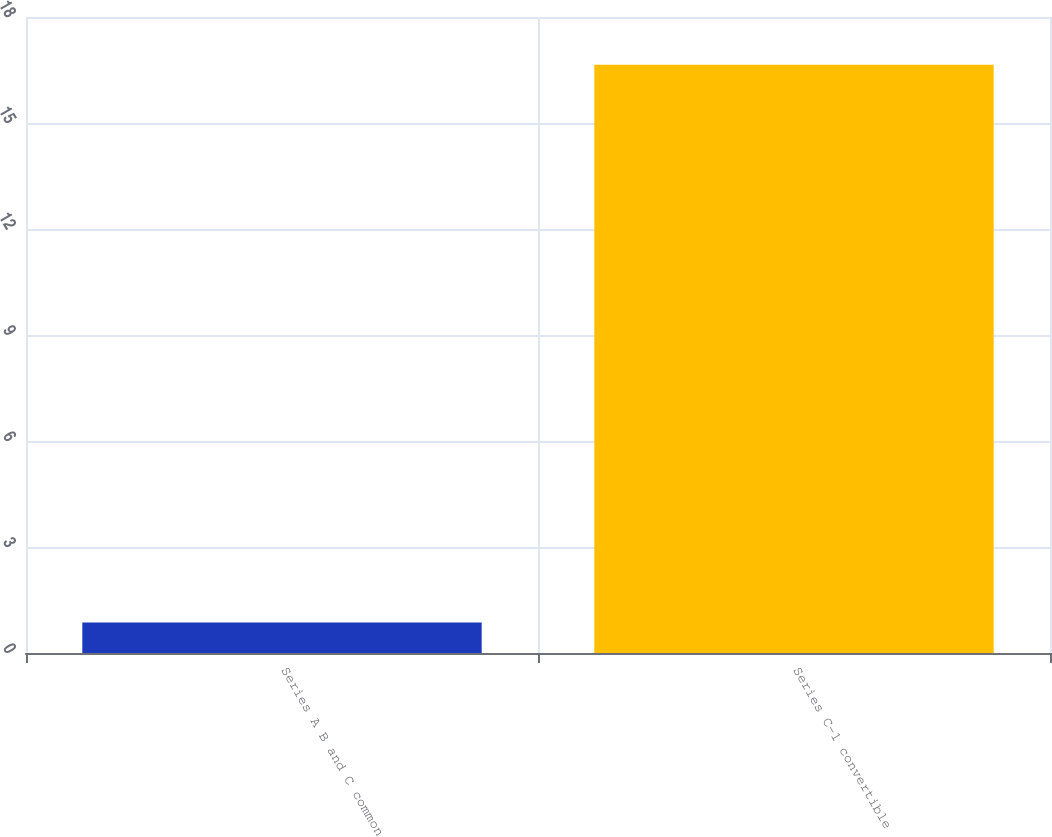<chart> <loc_0><loc_0><loc_500><loc_500><bar_chart><fcel>Series A B and C common<fcel>Series C-1 convertible<nl><fcel>0.86<fcel>16.65<nl></chart> 